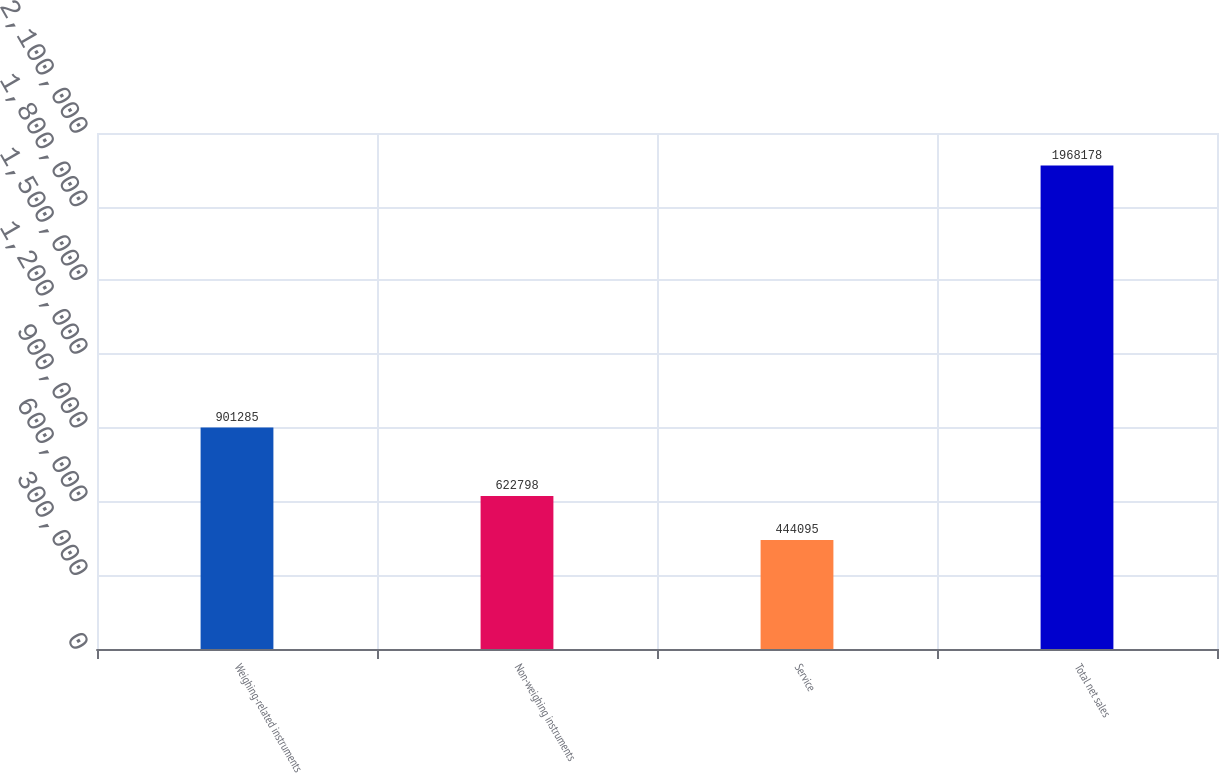<chart> <loc_0><loc_0><loc_500><loc_500><bar_chart><fcel>Weighing-related instruments<fcel>Non-weighing instruments<fcel>Service<fcel>Total net sales<nl><fcel>901285<fcel>622798<fcel>444095<fcel>1.96818e+06<nl></chart> 